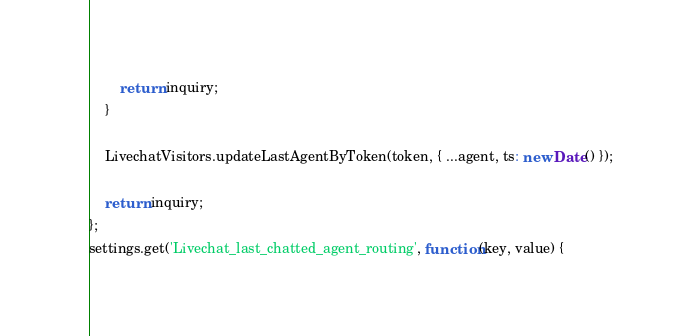Convert code to text. <code><loc_0><loc_0><loc_500><loc_500><_JavaScript_>		return inquiry;
	}

	LivechatVisitors.updateLastAgentByToken(token, { ...agent, ts: new Date() });

	return inquiry;
};
settings.get('Livechat_last_chatted_agent_routing', function(key, value) {</code> 